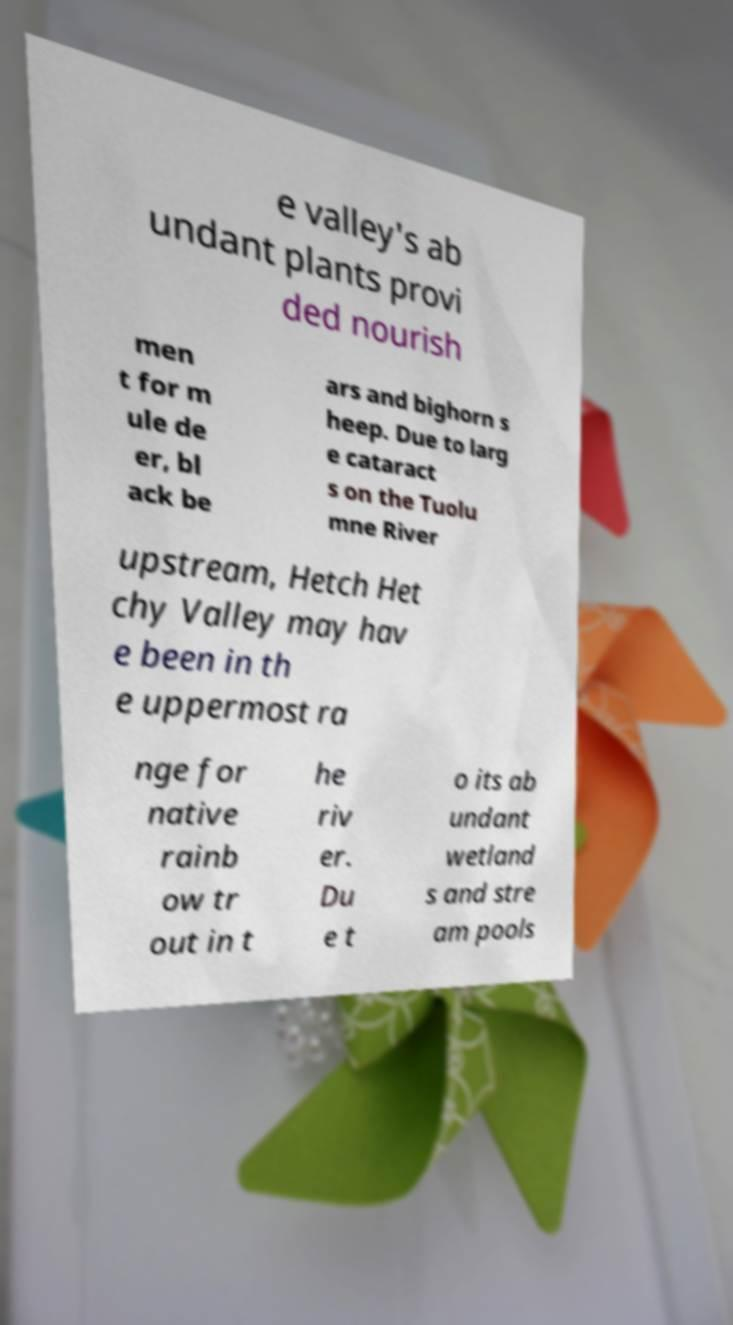Can you read and provide the text displayed in the image?This photo seems to have some interesting text. Can you extract and type it out for me? e valley's ab undant plants provi ded nourish men t for m ule de er, bl ack be ars and bighorn s heep. Due to larg e cataract s on the Tuolu mne River upstream, Hetch Het chy Valley may hav e been in th e uppermost ra nge for native rainb ow tr out in t he riv er. Du e t o its ab undant wetland s and stre am pools 